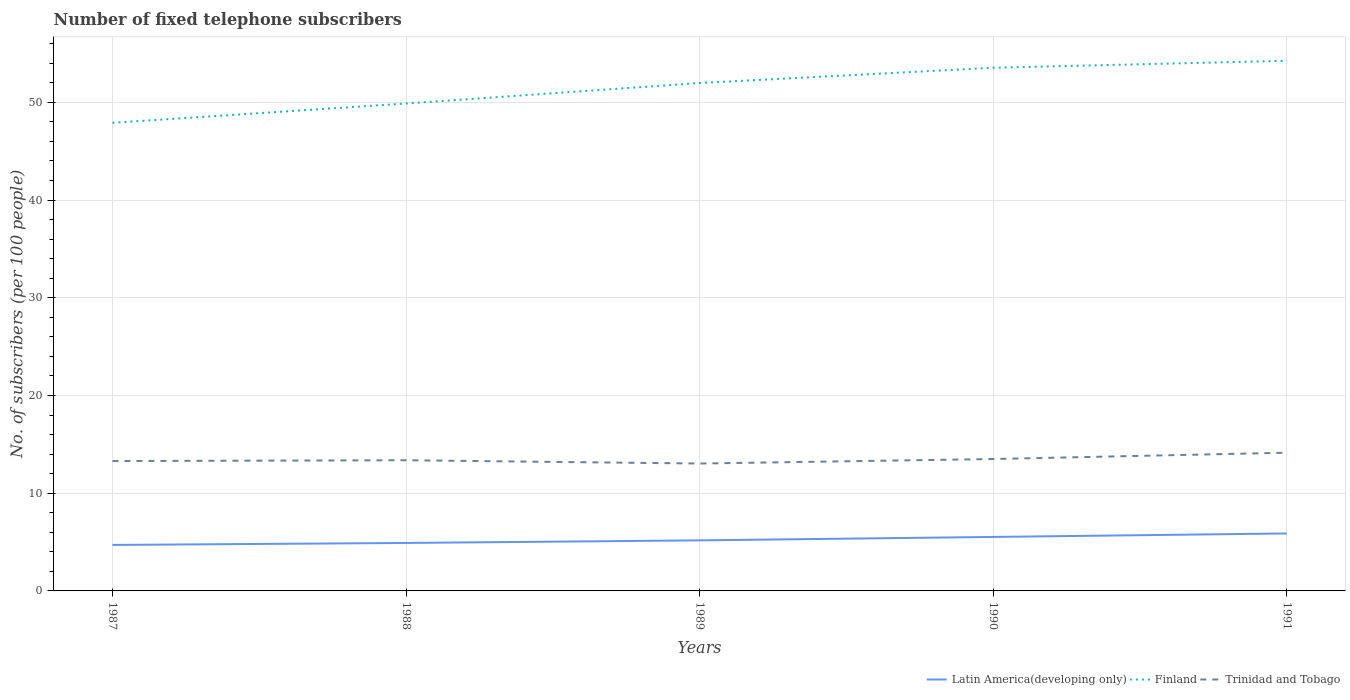How many different coloured lines are there?
Provide a short and direct response. 3. Is the number of lines equal to the number of legend labels?
Your answer should be very brief. Yes. Across all years, what is the maximum number of fixed telephone subscribers in Latin America(developing only)?
Your answer should be very brief. 4.71. In which year was the number of fixed telephone subscribers in Finland maximum?
Offer a very short reply. 1987. What is the total number of fixed telephone subscribers in Latin America(developing only) in the graph?
Provide a short and direct response. -0.82. What is the difference between the highest and the second highest number of fixed telephone subscribers in Trinidad and Tobago?
Your response must be concise. 1.11. What is the difference between the highest and the lowest number of fixed telephone subscribers in Finland?
Your response must be concise. 3. Is the number of fixed telephone subscribers in Finland strictly greater than the number of fixed telephone subscribers in Latin America(developing only) over the years?
Your answer should be very brief. No. How many lines are there?
Offer a very short reply. 3. Are the values on the major ticks of Y-axis written in scientific E-notation?
Provide a short and direct response. No. Does the graph contain any zero values?
Your answer should be very brief. No. Does the graph contain grids?
Make the answer very short. Yes. Where does the legend appear in the graph?
Provide a succinct answer. Bottom right. How are the legend labels stacked?
Give a very brief answer. Horizontal. What is the title of the graph?
Offer a very short reply. Number of fixed telephone subscribers. What is the label or title of the X-axis?
Your answer should be compact. Years. What is the label or title of the Y-axis?
Provide a succinct answer. No. of subscribers (per 100 people). What is the No. of subscribers (per 100 people) of Latin America(developing only) in 1987?
Offer a very short reply. 4.71. What is the No. of subscribers (per 100 people) in Finland in 1987?
Offer a terse response. 47.9. What is the No. of subscribers (per 100 people) in Trinidad and Tobago in 1987?
Provide a succinct answer. 13.29. What is the No. of subscribers (per 100 people) in Latin America(developing only) in 1988?
Provide a succinct answer. 4.91. What is the No. of subscribers (per 100 people) of Finland in 1988?
Keep it short and to the point. 49.88. What is the No. of subscribers (per 100 people) in Trinidad and Tobago in 1988?
Offer a very short reply. 13.37. What is the No. of subscribers (per 100 people) of Latin America(developing only) in 1989?
Your response must be concise. 5.17. What is the No. of subscribers (per 100 people) in Finland in 1989?
Keep it short and to the point. 51.97. What is the No. of subscribers (per 100 people) of Trinidad and Tobago in 1989?
Your answer should be very brief. 13.04. What is the No. of subscribers (per 100 people) in Latin America(developing only) in 1990?
Make the answer very short. 5.52. What is the No. of subscribers (per 100 people) in Finland in 1990?
Provide a short and direct response. 53.54. What is the No. of subscribers (per 100 people) in Trinidad and Tobago in 1990?
Ensure brevity in your answer.  13.5. What is the No. of subscribers (per 100 people) of Latin America(developing only) in 1991?
Your response must be concise. 5.88. What is the No. of subscribers (per 100 people) of Finland in 1991?
Your answer should be very brief. 54.25. What is the No. of subscribers (per 100 people) in Trinidad and Tobago in 1991?
Make the answer very short. 14.14. Across all years, what is the maximum No. of subscribers (per 100 people) of Latin America(developing only)?
Give a very brief answer. 5.88. Across all years, what is the maximum No. of subscribers (per 100 people) in Finland?
Your answer should be compact. 54.25. Across all years, what is the maximum No. of subscribers (per 100 people) of Trinidad and Tobago?
Ensure brevity in your answer.  14.14. Across all years, what is the minimum No. of subscribers (per 100 people) of Latin America(developing only)?
Keep it short and to the point. 4.71. Across all years, what is the minimum No. of subscribers (per 100 people) in Finland?
Offer a terse response. 47.9. Across all years, what is the minimum No. of subscribers (per 100 people) in Trinidad and Tobago?
Provide a succinct answer. 13.04. What is the total No. of subscribers (per 100 people) in Latin America(developing only) in the graph?
Your answer should be very brief. 26.19. What is the total No. of subscribers (per 100 people) of Finland in the graph?
Offer a very short reply. 257.54. What is the total No. of subscribers (per 100 people) in Trinidad and Tobago in the graph?
Keep it short and to the point. 67.34. What is the difference between the No. of subscribers (per 100 people) of Latin America(developing only) in 1987 and that in 1988?
Your answer should be very brief. -0.2. What is the difference between the No. of subscribers (per 100 people) in Finland in 1987 and that in 1988?
Provide a succinct answer. -1.98. What is the difference between the No. of subscribers (per 100 people) of Trinidad and Tobago in 1987 and that in 1988?
Your answer should be very brief. -0.08. What is the difference between the No. of subscribers (per 100 people) of Latin America(developing only) in 1987 and that in 1989?
Ensure brevity in your answer.  -0.47. What is the difference between the No. of subscribers (per 100 people) of Finland in 1987 and that in 1989?
Provide a short and direct response. -4.07. What is the difference between the No. of subscribers (per 100 people) in Trinidad and Tobago in 1987 and that in 1989?
Your response must be concise. 0.25. What is the difference between the No. of subscribers (per 100 people) of Latin America(developing only) in 1987 and that in 1990?
Your response must be concise. -0.82. What is the difference between the No. of subscribers (per 100 people) in Finland in 1987 and that in 1990?
Offer a very short reply. -5.64. What is the difference between the No. of subscribers (per 100 people) of Trinidad and Tobago in 1987 and that in 1990?
Provide a short and direct response. -0.21. What is the difference between the No. of subscribers (per 100 people) of Latin America(developing only) in 1987 and that in 1991?
Ensure brevity in your answer.  -1.18. What is the difference between the No. of subscribers (per 100 people) of Finland in 1987 and that in 1991?
Offer a terse response. -6.35. What is the difference between the No. of subscribers (per 100 people) in Trinidad and Tobago in 1987 and that in 1991?
Provide a short and direct response. -0.85. What is the difference between the No. of subscribers (per 100 people) in Latin America(developing only) in 1988 and that in 1989?
Offer a terse response. -0.27. What is the difference between the No. of subscribers (per 100 people) of Finland in 1988 and that in 1989?
Offer a very short reply. -2.1. What is the difference between the No. of subscribers (per 100 people) of Trinidad and Tobago in 1988 and that in 1989?
Provide a short and direct response. 0.34. What is the difference between the No. of subscribers (per 100 people) in Latin America(developing only) in 1988 and that in 1990?
Keep it short and to the point. -0.62. What is the difference between the No. of subscribers (per 100 people) in Finland in 1988 and that in 1990?
Your response must be concise. -3.66. What is the difference between the No. of subscribers (per 100 people) in Trinidad and Tobago in 1988 and that in 1990?
Ensure brevity in your answer.  -0.13. What is the difference between the No. of subscribers (per 100 people) of Latin America(developing only) in 1988 and that in 1991?
Your answer should be very brief. -0.97. What is the difference between the No. of subscribers (per 100 people) in Finland in 1988 and that in 1991?
Ensure brevity in your answer.  -4.37. What is the difference between the No. of subscribers (per 100 people) of Trinidad and Tobago in 1988 and that in 1991?
Your answer should be compact. -0.77. What is the difference between the No. of subscribers (per 100 people) in Latin America(developing only) in 1989 and that in 1990?
Make the answer very short. -0.35. What is the difference between the No. of subscribers (per 100 people) in Finland in 1989 and that in 1990?
Keep it short and to the point. -1.56. What is the difference between the No. of subscribers (per 100 people) of Trinidad and Tobago in 1989 and that in 1990?
Make the answer very short. -0.46. What is the difference between the No. of subscribers (per 100 people) of Latin America(developing only) in 1989 and that in 1991?
Your answer should be very brief. -0.71. What is the difference between the No. of subscribers (per 100 people) of Finland in 1989 and that in 1991?
Make the answer very short. -2.28. What is the difference between the No. of subscribers (per 100 people) in Trinidad and Tobago in 1989 and that in 1991?
Give a very brief answer. -1.11. What is the difference between the No. of subscribers (per 100 people) in Latin America(developing only) in 1990 and that in 1991?
Offer a very short reply. -0.36. What is the difference between the No. of subscribers (per 100 people) of Finland in 1990 and that in 1991?
Make the answer very short. -0.71. What is the difference between the No. of subscribers (per 100 people) of Trinidad and Tobago in 1990 and that in 1991?
Offer a terse response. -0.65. What is the difference between the No. of subscribers (per 100 people) of Latin America(developing only) in 1987 and the No. of subscribers (per 100 people) of Finland in 1988?
Ensure brevity in your answer.  -45.17. What is the difference between the No. of subscribers (per 100 people) in Latin America(developing only) in 1987 and the No. of subscribers (per 100 people) in Trinidad and Tobago in 1988?
Provide a succinct answer. -8.67. What is the difference between the No. of subscribers (per 100 people) of Finland in 1987 and the No. of subscribers (per 100 people) of Trinidad and Tobago in 1988?
Ensure brevity in your answer.  34.53. What is the difference between the No. of subscribers (per 100 people) of Latin America(developing only) in 1987 and the No. of subscribers (per 100 people) of Finland in 1989?
Make the answer very short. -47.27. What is the difference between the No. of subscribers (per 100 people) of Latin America(developing only) in 1987 and the No. of subscribers (per 100 people) of Trinidad and Tobago in 1989?
Your answer should be compact. -8.33. What is the difference between the No. of subscribers (per 100 people) of Finland in 1987 and the No. of subscribers (per 100 people) of Trinidad and Tobago in 1989?
Your response must be concise. 34.87. What is the difference between the No. of subscribers (per 100 people) of Latin America(developing only) in 1987 and the No. of subscribers (per 100 people) of Finland in 1990?
Give a very brief answer. -48.83. What is the difference between the No. of subscribers (per 100 people) in Latin America(developing only) in 1987 and the No. of subscribers (per 100 people) in Trinidad and Tobago in 1990?
Offer a terse response. -8.79. What is the difference between the No. of subscribers (per 100 people) of Finland in 1987 and the No. of subscribers (per 100 people) of Trinidad and Tobago in 1990?
Provide a short and direct response. 34.4. What is the difference between the No. of subscribers (per 100 people) in Latin America(developing only) in 1987 and the No. of subscribers (per 100 people) in Finland in 1991?
Keep it short and to the point. -49.54. What is the difference between the No. of subscribers (per 100 people) in Latin America(developing only) in 1987 and the No. of subscribers (per 100 people) in Trinidad and Tobago in 1991?
Offer a terse response. -9.44. What is the difference between the No. of subscribers (per 100 people) of Finland in 1987 and the No. of subscribers (per 100 people) of Trinidad and Tobago in 1991?
Your response must be concise. 33.76. What is the difference between the No. of subscribers (per 100 people) in Latin America(developing only) in 1988 and the No. of subscribers (per 100 people) in Finland in 1989?
Provide a succinct answer. -47.07. What is the difference between the No. of subscribers (per 100 people) in Latin America(developing only) in 1988 and the No. of subscribers (per 100 people) in Trinidad and Tobago in 1989?
Keep it short and to the point. -8.13. What is the difference between the No. of subscribers (per 100 people) in Finland in 1988 and the No. of subscribers (per 100 people) in Trinidad and Tobago in 1989?
Give a very brief answer. 36.84. What is the difference between the No. of subscribers (per 100 people) in Latin America(developing only) in 1988 and the No. of subscribers (per 100 people) in Finland in 1990?
Provide a succinct answer. -48.63. What is the difference between the No. of subscribers (per 100 people) in Latin America(developing only) in 1988 and the No. of subscribers (per 100 people) in Trinidad and Tobago in 1990?
Offer a terse response. -8.59. What is the difference between the No. of subscribers (per 100 people) of Finland in 1988 and the No. of subscribers (per 100 people) of Trinidad and Tobago in 1990?
Offer a terse response. 36.38. What is the difference between the No. of subscribers (per 100 people) in Latin America(developing only) in 1988 and the No. of subscribers (per 100 people) in Finland in 1991?
Your response must be concise. -49.34. What is the difference between the No. of subscribers (per 100 people) of Latin America(developing only) in 1988 and the No. of subscribers (per 100 people) of Trinidad and Tobago in 1991?
Your answer should be very brief. -9.24. What is the difference between the No. of subscribers (per 100 people) of Finland in 1988 and the No. of subscribers (per 100 people) of Trinidad and Tobago in 1991?
Provide a succinct answer. 35.74. What is the difference between the No. of subscribers (per 100 people) in Latin America(developing only) in 1989 and the No. of subscribers (per 100 people) in Finland in 1990?
Give a very brief answer. -48.36. What is the difference between the No. of subscribers (per 100 people) in Latin America(developing only) in 1989 and the No. of subscribers (per 100 people) in Trinidad and Tobago in 1990?
Make the answer very short. -8.32. What is the difference between the No. of subscribers (per 100 people) in Finland in 1989 and the No. of subscribers (per 100 people) in Trinidad and Tobago in 1990?
Your response must be concise. 38.48. What is the difference between the No. of subscribers (per 100 people) in Latin America(developing only) in 1989 and the No. of subscribers (per 100 people) in Finland in 1991?
Make the answer very short. -49.08. What is the difference between the No. of subscribers (per 100 people) of Latin America(developing only) in 1989 and the No. of subscribers (per 100 people) of Trinidad and Tobago in 1991?
Offer a terse response. -8.97. What is the difference between the No. of subscribers (per 100 people) in Finland in 1989 and the No. of subscribers (per 100 people) in Trinidad and Tobago in 1991?
Your response must be concise. 37.83. What is the difference between the No. of subscribers (per 100 people) of Latin America(developing only) in 1990 and the No. of subscribers (per 100 people) of Finland in 1991?
Offer a very short reply. -48.73. What is the difference between the No. of subscribers (per 100 people) of Latin America(developing only) in 1990 and the No. of subscribers (per 100 people) of Trinidad and Tobago in 1991?
Ensure brevity in your answer.  -8.62. What is the difference between the No. of subscribers (per 100 people) in Finland in 1990 and the No. of subscribers (per 100 people) in Trinidad and Tobago in 1991?
Keep it short and to the point. 39.39. What is the average No. of subscribers (per 100 people) in Latin America(developing only) per year?
Provide a short and direct response. 5.24. What is the average No. of subscribers (per 100 people) of Finland per year?
Keep it short and to the point. 51.51. What is the average No. of subscribers (per 100 people) of Trinidad and Tobago per year?
Keep it short and to the point. 13.47. In the year 1987, what is the difference between the No. of subscribers (per 100 people) in Latin America(developing only) and No. of subscribers (per 100 people) in Finland?
Your answer should be very brief. -43.2. In the year 1987, what is the difference between the No. of subscribers (per 100 people) in Latin America(developing only) and No. of subscribers (per 100 people) in Trinidad and Tobago?
Provide a short and direct response. -8.58. In the year 1987, what is the difference between the No. of subscribers (per 100 people) in Finland and No. of subscribers (per 100 people) in Trinidad and Tobago?
Make the answer very short. 34.61. In the year 1988, what is the difference between the No. of subscribers (per 100 people) in Latin America(developing only) and No. of subscribers (per 100 people) in Finland?
Keep it short and to the point. -44.97. In the year 1988, what is the difference between the No. of subscribers (per 100 people) of Latin America(developing only) and No. of subscribers (per 100 people) of Trinidad and Tobago?
Keep it short and to the point. -8.46. In the year 1988, what is the difference between the No. of subscribers (per 100 people) in Finland and No. of subscribers (per 100 people) in Trinidad and Tobago?
Offer a very short reply. 36.51. In the year 1989, what is the difference between the No. of subscribers (per 100 people) of Latin America(developing only) and No. of subscribers (per 100 people) of Finland?
Keep it short and to the point. -46.8. In the year 1989, what is the difference between the No. of subscribers (per 100 people) of Latin America(developing only) and No. of subscribers (per 100 people) of Trinidad and Tobago?
Ensure brevity in your answer.  -7.86. In the year 1989, what is the difference between the No. of subscribers (per 100 people) of Finland and No. of subscribers (per 100 people) of Trinidad and Tobago?
Give a very brief answer. 38.94. In the year 1990, what is the difference between the No. of subscribers (per 100 people) of Latin America(developing only) and No. of subscribers (per 100 people) of Finland?
Provide a short and direct response. -48.01. In the year 1990, what is the difference between the No. of subscribers (per 100 people) in Latin America(developing only) and No. of subscribers (per 100 people) in Trinidad and Tobago?
Your answer should be compact. -7.97. In the year 1990, what is the difference between the No. of subscribers (per 100 people) in Finland and No. of subscribers (per 100 people) in Trinidad and Tobago?
Keep it short and to the point. 40.04. In the year 1991, what is the difference between the No. of subscribers (per 100 people) in Latin America(developing only) and No. of subscribers (per 100 people) in Finland?
Make the answer very short. -48.37. In the year 1991, what is the difference between the No. of subscribers (per 100 people) in Latin America(developing only) and No. of subscribers (per 100 people) in Trinidad and Tobago?
Your response must be concise. -8.26. In the year 1991, what is the difference between the No. of subscribers (per 100 people) of Finland and No. of subscribers (per 100 people) of Trinidad and Tobago?
Your answer should be very brief. 40.11. What is the ratio of the No. of subscribers (per 100 people) of Latin America(developing only) in 1987 to that in 1988?
Offer a very short reply. 0.96. What is the ratio of the No. of subscribers (per 100 people) in Finland in 1987 to that in 1988?
Provide a short and direct response. 0.96. What is the ratio of the No. of subscribers (per 100 people) of Latin America(developing only) in 1987 to that in 1989?
Your answer should be very brief. 0.91. What is the ratio of the No. of subscribers (per 100 people) of Finland in 1987 to that in 1989?
Your answer should be compact. 0.92. What is the ratio of the No. of subscribers (per 100 people) in Trinidad and Tobago in 1987 to that in 1989?
Provide a succinct answer. 1.02. What is the ratio of the No. of subscribers (per 100 people) of Latin America(developing only) in 1987 to that in 1990?
Your response must be concise. 0.85. What is the ratio of the No. of subscribers (per 100 people) in Finland in 1987 to that in 1990?
Make the answer very short. 0.89. What is the ratio of the No. of subscribers (per 100 people) in Trinidad and Tobago in 1987 to that in 1990?
Provide a succinct answer. 0.98. What is the ratio of the No. of subscribers (per 100 people) of Latin America(developing only) in 1987 to that in 1991?
Provide a short and direct response. 0.8. What is the ratio of the No. of subscribers (per 100 people) of Finland in 1987 to that in 1991?
Keep it short and to the point. 0.88. What is the ratio of the No. of subscribers (per 100 people) of Trinidad and Tobago in 1987 to that in 1991?
Give a very brief answer. 0.94. What is the ratio of the No. of subscribers (per 100 people) of Latin America(developing only) in 1988 to that in 1989?
Provide a short and direct response. 0.95. What is the ratio of the No. of subscribers (per 100 people) in Finland in 1988 to that in 1989?
Offer a terse response. 0.96. What is the ratio of the No. of subscribers (per 100 people) in Trinidad and Tobago in 1988 to that in 1989?
Keep it short and to the point. 1.03. What is the ratio of the No. of subscribers (per 100 people) in Latin America(developing only) in 1988 to that in 1990?
Your answer should be compact. 0.89. What is the ratio of the No. of subscribers (per 100 people) of Finland in 1988 to that in 1990?
Provide a short and direct response. 0.93. What is the ratio of the No. of subscribers (per 100 people) of Trinidad and Tobago in 1988 to that in 1990?
Ensure brevity in your answer.  0.99. What is the ratio of the No. of subscribers (per 100 people) of Latin America(developing only) in 1988 to that in 1991?
Your answer should be very brief. 0.83. What is the ratio of the No. of subscribers (per 100 people) in Finland in 1988 to that in 1991?
Ensure brevity in your answer.  0.92. What is the ratio of the No. of subscribers (per 100 people) in Trinidad and Tobago in 1988 to that in 1991?
Provide a short and direct response. 0.95. What is the ratio of the No. of subscribers (per 100 people) in Latin America(developing only) in 1989 to that in 1990?
Provide a succinct answer. 0.94. What is the ratio of the No. of subscribers (per 100 people) in Finland in 1989 to that in 1990?
Offer a very short reply. 0.97. What is the ratio of the No. of subscribers (per 100 people) of Trinidad and Tobago in 1989 to that in 1990?
Offer a terse response. 0.97. What is the ratio of the No. of subscribers (per 100 people) in Latin America(developing only) in 1989 to that in 1991?
Your answer should be very brief. 0.88. What is the ratio of the No. of subscribers (per 100 people) of Finland in 1989 to that in 1991?
Give a very brief answer. 0.96. What is the ratio of the No. of subscribers (per 100 people) of Trinidad and Tobago in 1989 to that in 1991?
Give a very brief answer. 0.92. What is the ratio of the No. of subscribers (per 100 people) of Latin America(developing only) in 1990 to that in 1991?
Provide a short and direct response. 0.94. What is the ratio of the No. of subscribers (per 100 people) of Finland in 1990 to that in 1991?
Offer a terse response. 0.99. What is the ratio of the No. of subscribers (per 100 people) in Trinidad and Tobago in 1990 to that in 1991?
Offer a terse response. 0.95. What is the difference between the highest and the second highest No. of subscribers (per 100 people) in Latin America(developing only)?
Provide a succinct answer. 0.36. What is the difference between the highest and the second highest No. of subscribers (per 100 people) in Finland?
Give a very brief answer. 0.71. What is the difference between the highest and the second highest No. of subscribers (per 100 people) in Trinidad and Tobago?
Your answer should be very brief. 0.65. What is the difference between the highest and the lowest No. of subscribers (per 100 people) in Latin America(developing only)?
Ensure brevity in your answer.  1.18. What is the difference between the highest and the lowest No. of subscribers (per 100 people) of Finland?
Give a very brief answer. 6.35. What is the difference between the highest and the lowest No. of subscribers (per 100 people) of Trinidad and Tobago?
Provide a short and direct response. 1.11. 